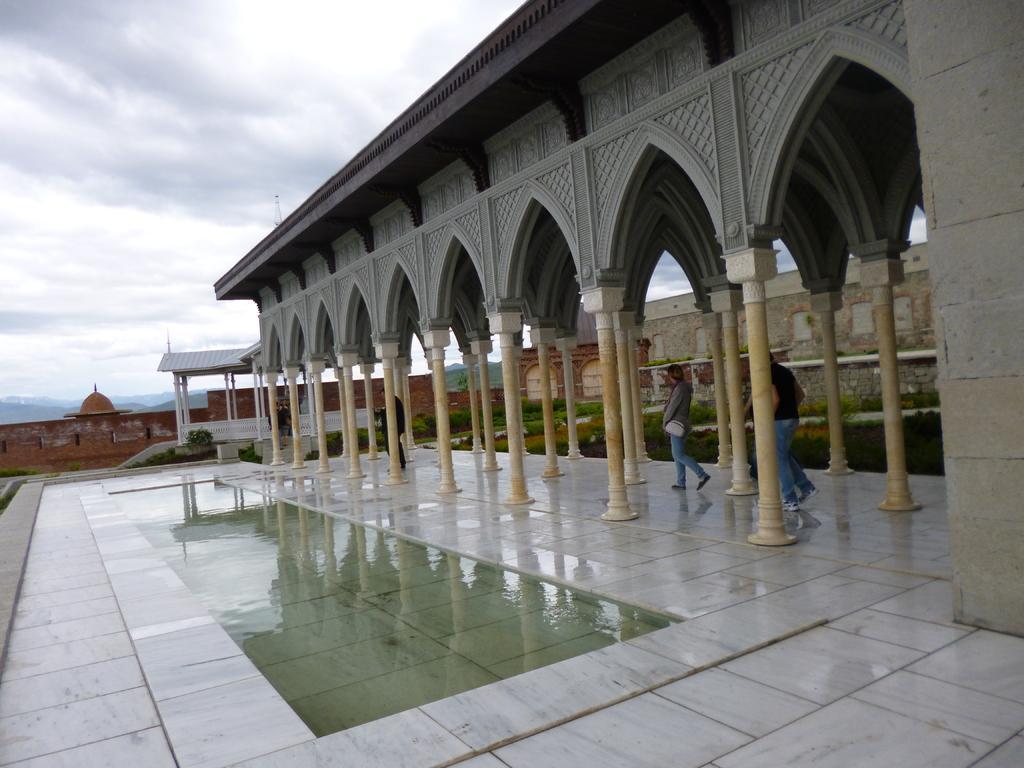Describe this image in one or two sentences. In this image, we can see pillars, shed, walls, plants, railings, people and water. Here we can see carvings. Background we can see hills and cloudy sky. 